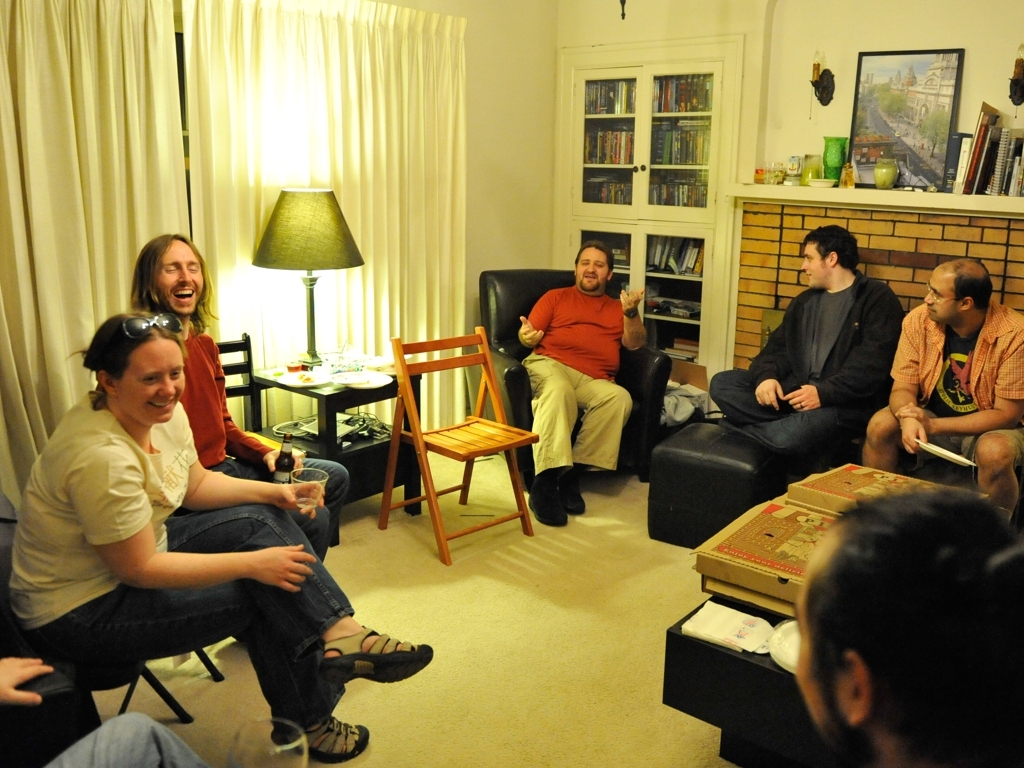What seems to be the occasion here? The image depicts a casual and friendly gathering, potentially a game night or a small party. The relaxed attire and genuine smiles suggest an intimate and informal event among friends. Is there anything that indicates what time of day this event is taking place? Given the soft lighting coming from lamps and the absence of daylight from the window, it's plausible to assume this gathering is taking place during the evening hours. 